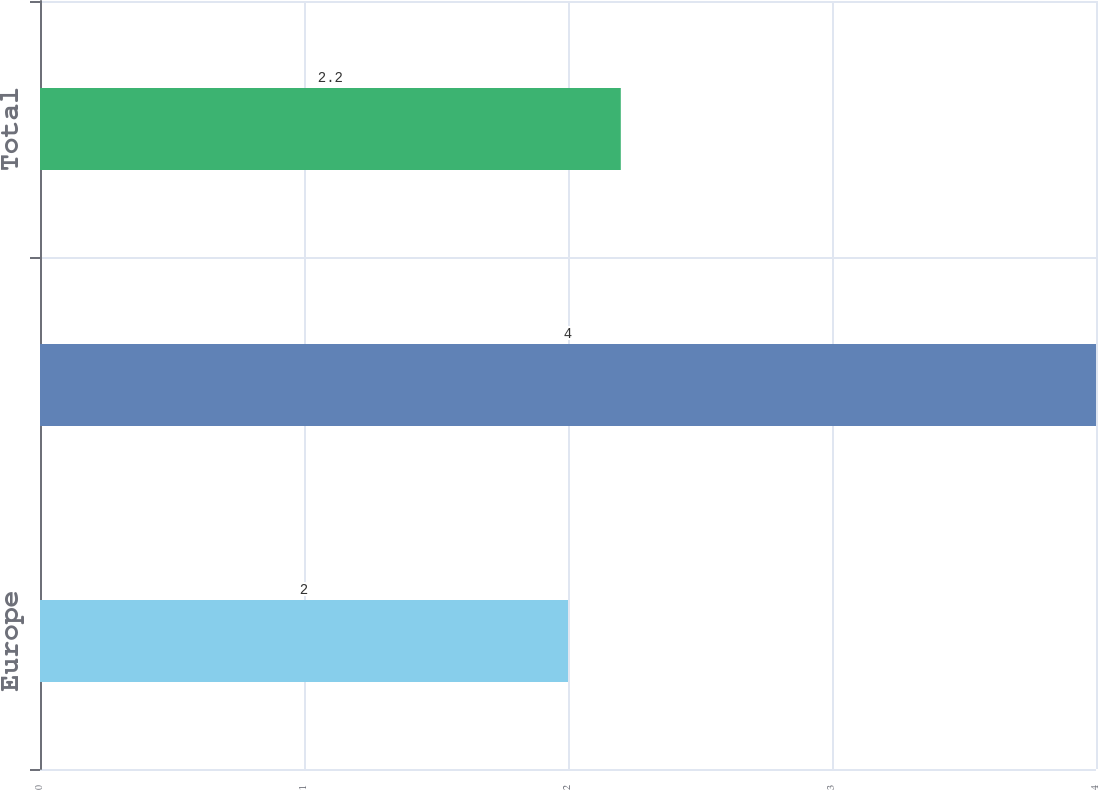<chart> <loc_0><loc_0><loc_500><loc_500><bar_chart><fcel>Europe<fcel>Rest of the World<fcel>Total<nl><fcel>2<fcel>4<fcel>2.2<nl></chart> 